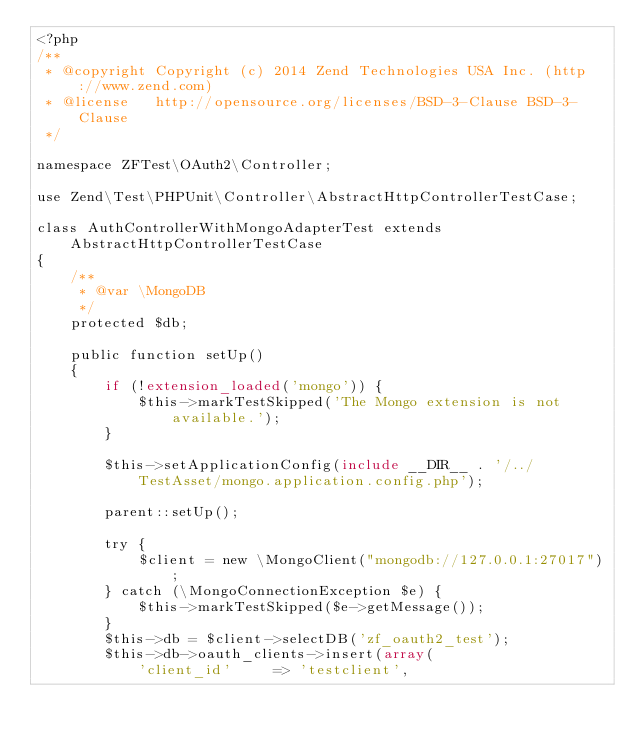Convert code to text. <code><loc_0><loc_0><loc_500><loc_500><_PHP_><?php
/**
 * @copyright Copyright (c) 2014 Zend Technologies USA Inc. (http://www.zend.com)
 * @license   http://opensource.org/licenses/BSD-3-Clause BSD-3-Clause
 */

namespace ZFTest\OAuth2\Controller;

use Zend\Test\PHPUnit\Controller\AbstractHttpControllerTestCase;

class AuthControllerWithMongoAdapterTest extends AbstractHttpControllerTestCase
{
    /**
     * @var \MongoDB
     */
    protected $db;

    public function setUp()
    {
        if (!extension_loaded('mongo')) {
            $this->markTestSkipped('The Mongo extension is not available.');
        }

        $this->setApplicationConfig(include __DIR__ . '/../TestAsset/mongo.application.config.php');

        parent::setUp();

        try {
            $client = new \MongoClient("mongodb://127.0.0.1:27017");
        } catch (\MongoConnectionException $e) {
            $this->markTestSkipped($e->getMessage());
        }
        $this->db = $client->selectDB('zf_oauth2_test');
        $this->db->oauth_clients->insert(array(
            'client_id'     => 'testclient',</code> 